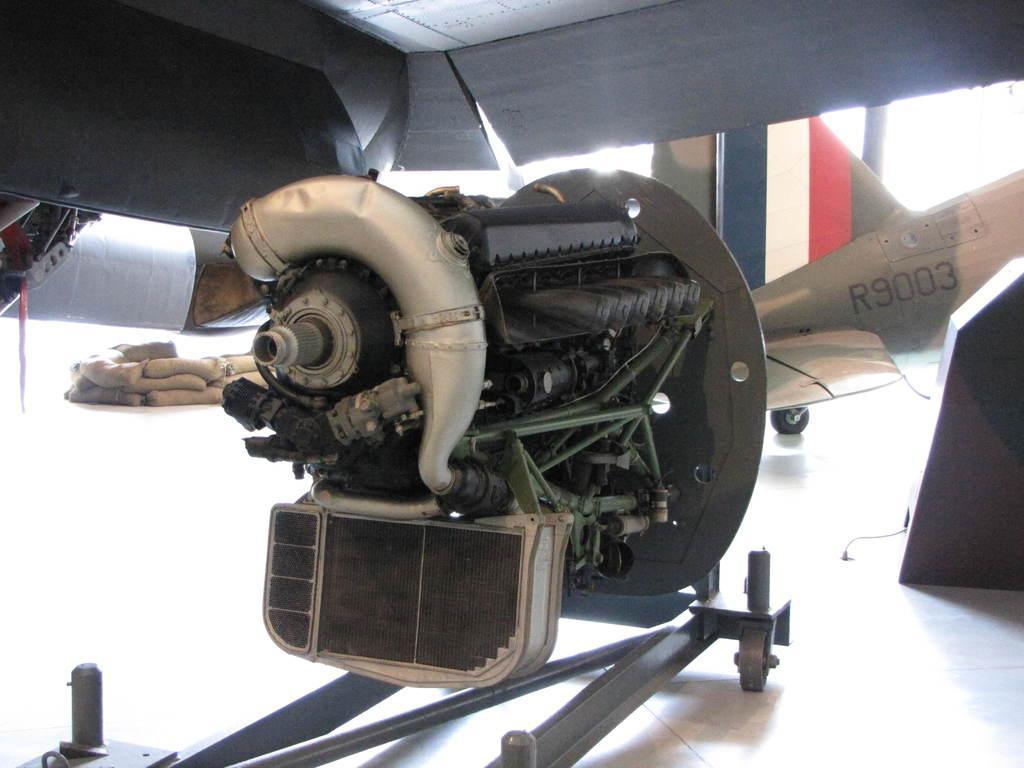How would you summarize this image in a sentence or two? In this image we can see an engine, aeroplane, bags, floor, and few metal objects. 